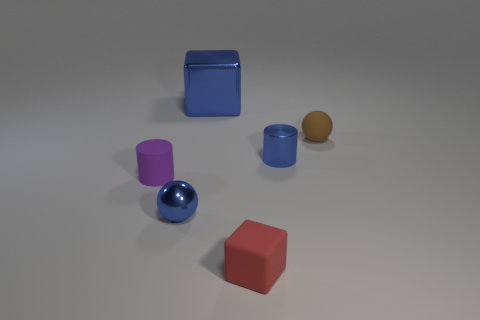Add 3 large purple balls. How many objects exist? 9 Subtract all cylinders. How many objects are left? 4 Subtract all matte spheres. Subtract all large metallic cylinders. How many objects are left? 5 Add 4 blue metal cylinders. How many blue metal cylinders are left? 5 Add 5 large brown metal cylinders. How many large brown metal cylinders exist? 5 Subtract 0 cyan balls. How many objects are left? 6 